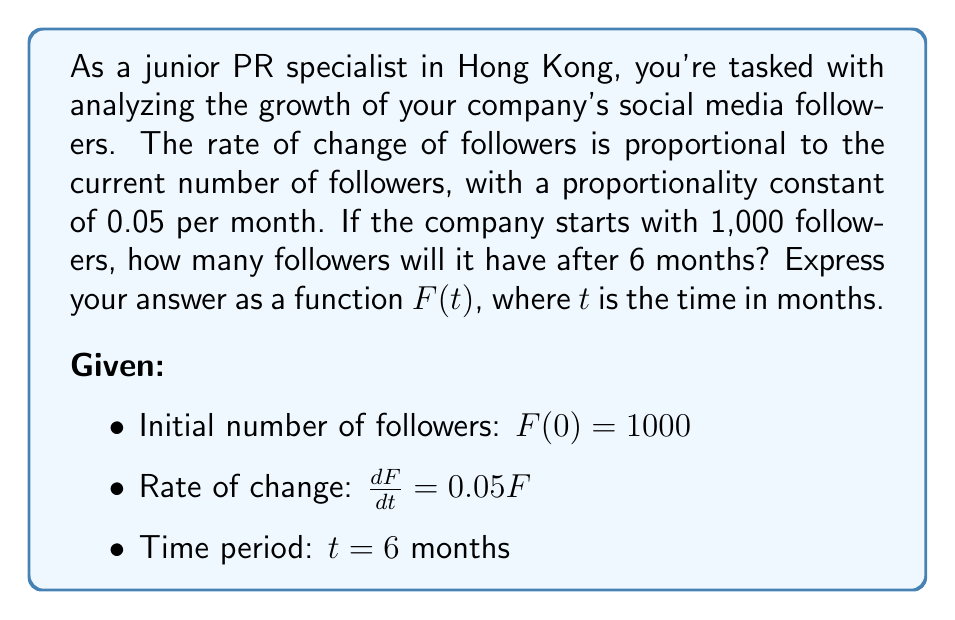Can you answer this question? 1) We recognize this as a first-order linear differential equation:

   $\frac{dF}{dt} = 0.05F$

2) This equation can be solved by separation of variables:

   $\frac{dF}{F} = 0.05dt$

3) Integrating both sides:

   $\int \frac{dF}{F} = \int 0.05dt$

   $\ln|F| = 0.05t + C$

4) Solving for $F$:

   $F = e^{0.05t + C} = e^C \cdot e^{0.05t}$

5) Let $A = e^C$. Then our general solution is:

   $F(t) = A \cdot e^{0.05t}$

6) Using the initial condition $F(0) = 1000$:

   $1000 = A \cdot e^{0.05 \cdot 0} = A$

7) Therefore, our particular solution is:

   $F(t) = 1000 \cdot e^{0.05t}$

8) To find the number of followers after 6 months, we evaluate $F(6)$:

   $F(6) = 1000 \cdot e^{0.05 \cdot 6} = 1000 \cdot e^{0.3} \approx 1349.86$
Answer: $F(t) = 1000e^{0.05t}$ 